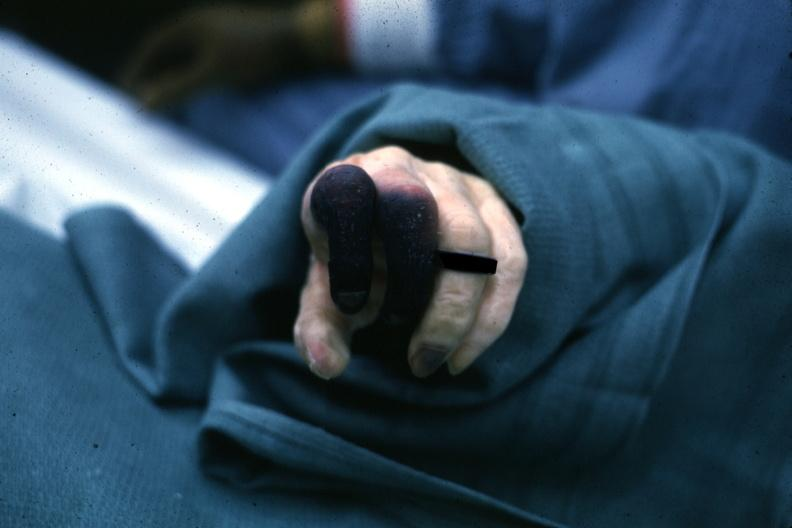re extremities present?
Answer the question using a single word or phrase. Yes 